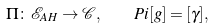Convert formula to latex. <formula><loc_0><loc_0><loc_500><loc_500>\Pi \colon { \mathcal { E } } _ { A H } \rightarrow { \mathcal { C } } , \quad P i [ g ] = [ \gamma ] ,</formula> 